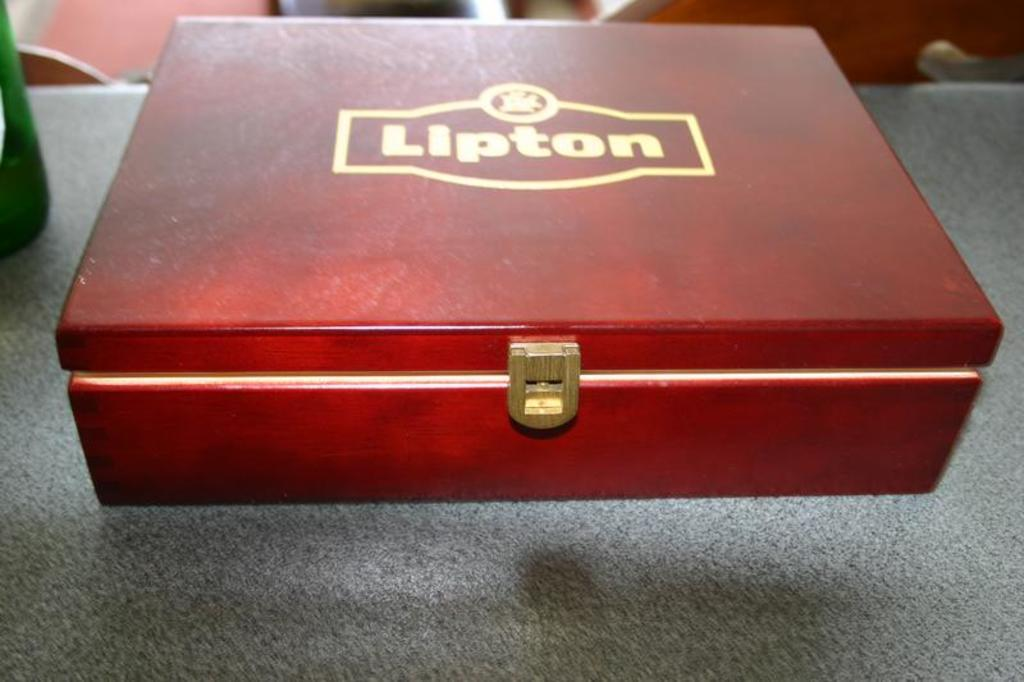<image>
Offer a succinct explanation of the picture presented. The rather nice case must contain Lipton products. 